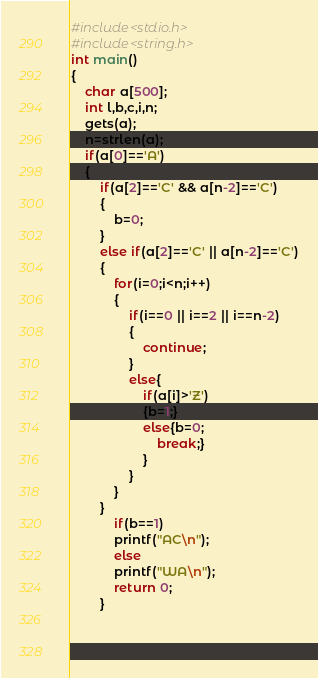Convert code to text. <code><loc_0><loc_0><loc_500><loc_500><_C_>#include<stdio.h>
#include<string.h>
int main()
{
	char a[500];
	int l,b,c,i,n;
	gets(a);
	n=strlen(a);
	if(a[0]=='A')
	{
		if(a[2]=='C' && a[n-2]=='C')
		{
			b=0;
		}
		else if(a[2]=='C' || a[n-2]=='C')
		{
			for(i=0;i<n;i++)
			{
				if(i==0 || i==2 || i==n-2)
				{
					continue;
				}
				else{
					if(a[i]>'Z')
					{b=1;}
					else{b=0;
						break;}
					}
				}
			}
		}
			if(b==1)
			printf("AC\n");
			else
			printf("WA\n");
			return 0;
		}
					
					
				
</code> 